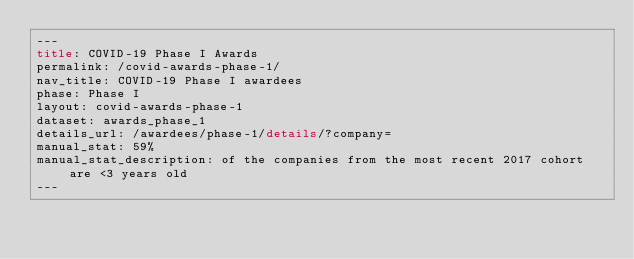<code> <loc_0><loc_0><loc_500><loc_500><_HTML_>---
title: COVID-19 Phase I Awards
permalink: /covid-awards-phase-1/
nav_title: COVID-19 Phase I awardees
phase: Phase I
layout: covid-awards-phase-1
dataset: awards_phase_1
details_url: /awardees/phase-1/details/?company=
manual_stat: 59%
manual_stat_description: of the companies from the most recent 2017 cohort are <3 years old
---
</code> 